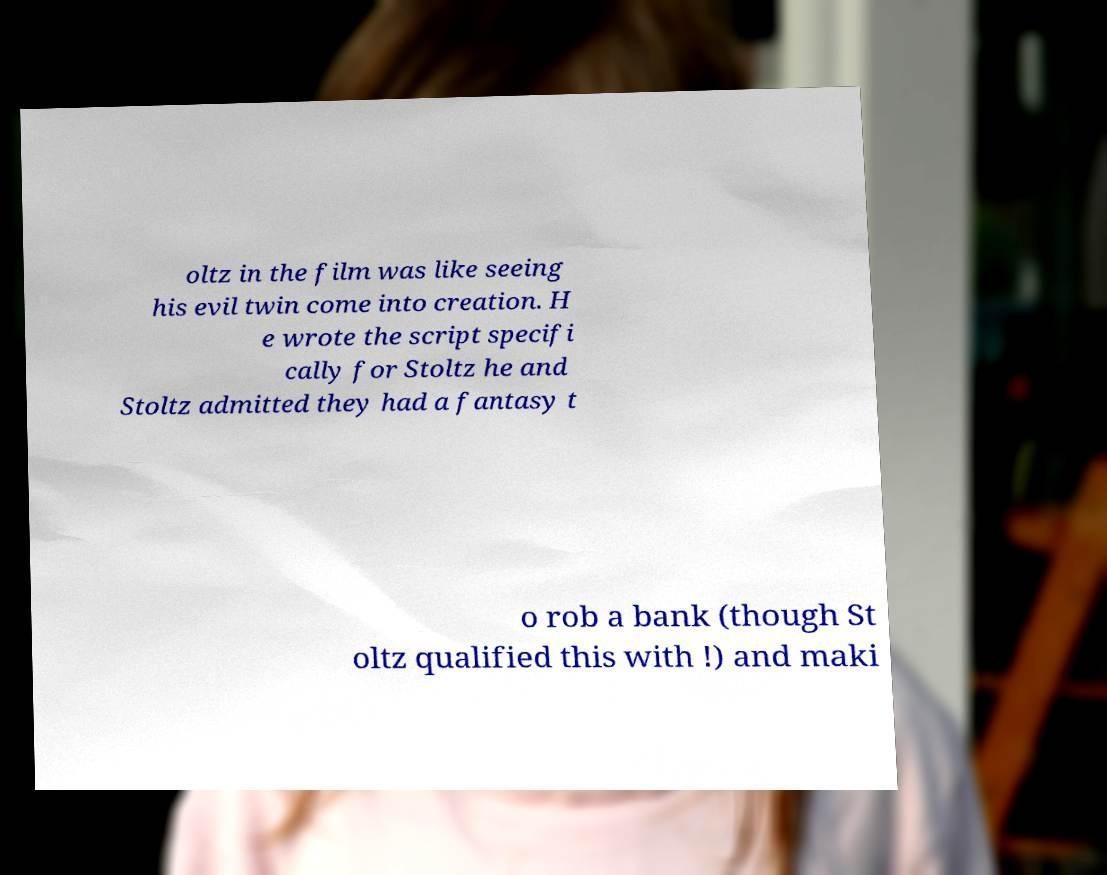Could you assist in decoding the text presented in this image and type it out clearly? oltz in the film was like seeing his evil twin come into creation. H e wrote the script specifi cally for Stoltz he and Stoltz admitted they had a fantasy t o rob a bank (though St oltz qualified this with !) and maki 